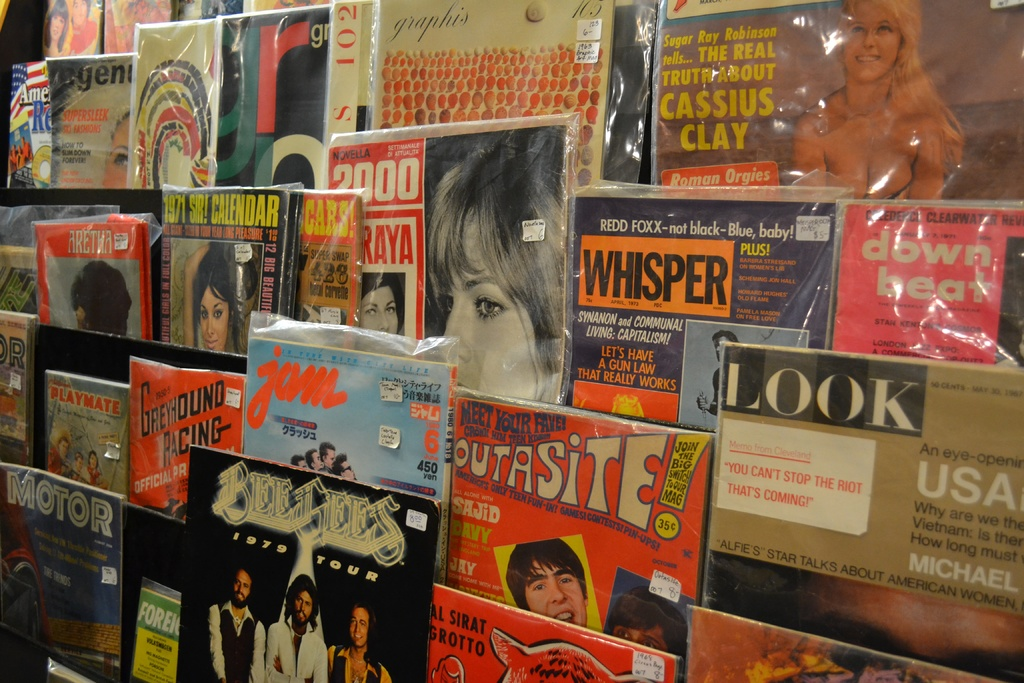Can you explain the historical significance of any specific magazine visible in this image? One notable magazine shown is 'Look', a popular American general-interest magazine from the mid-20th century which provided insightful photojournalism into American life and had a significant impact by bringing important social issues to the forefront through visual storytelling. How did magazines like 'Look' influence public opinion or social trends? Magazines like 'Look' played a crucial role in shaping public discourse by covering a diverse range of topics including politics, civil rights, and popular culture in a format that was both accessible and visually engaging, thus influencing readers' perceptions and contributing to broader social trends. 